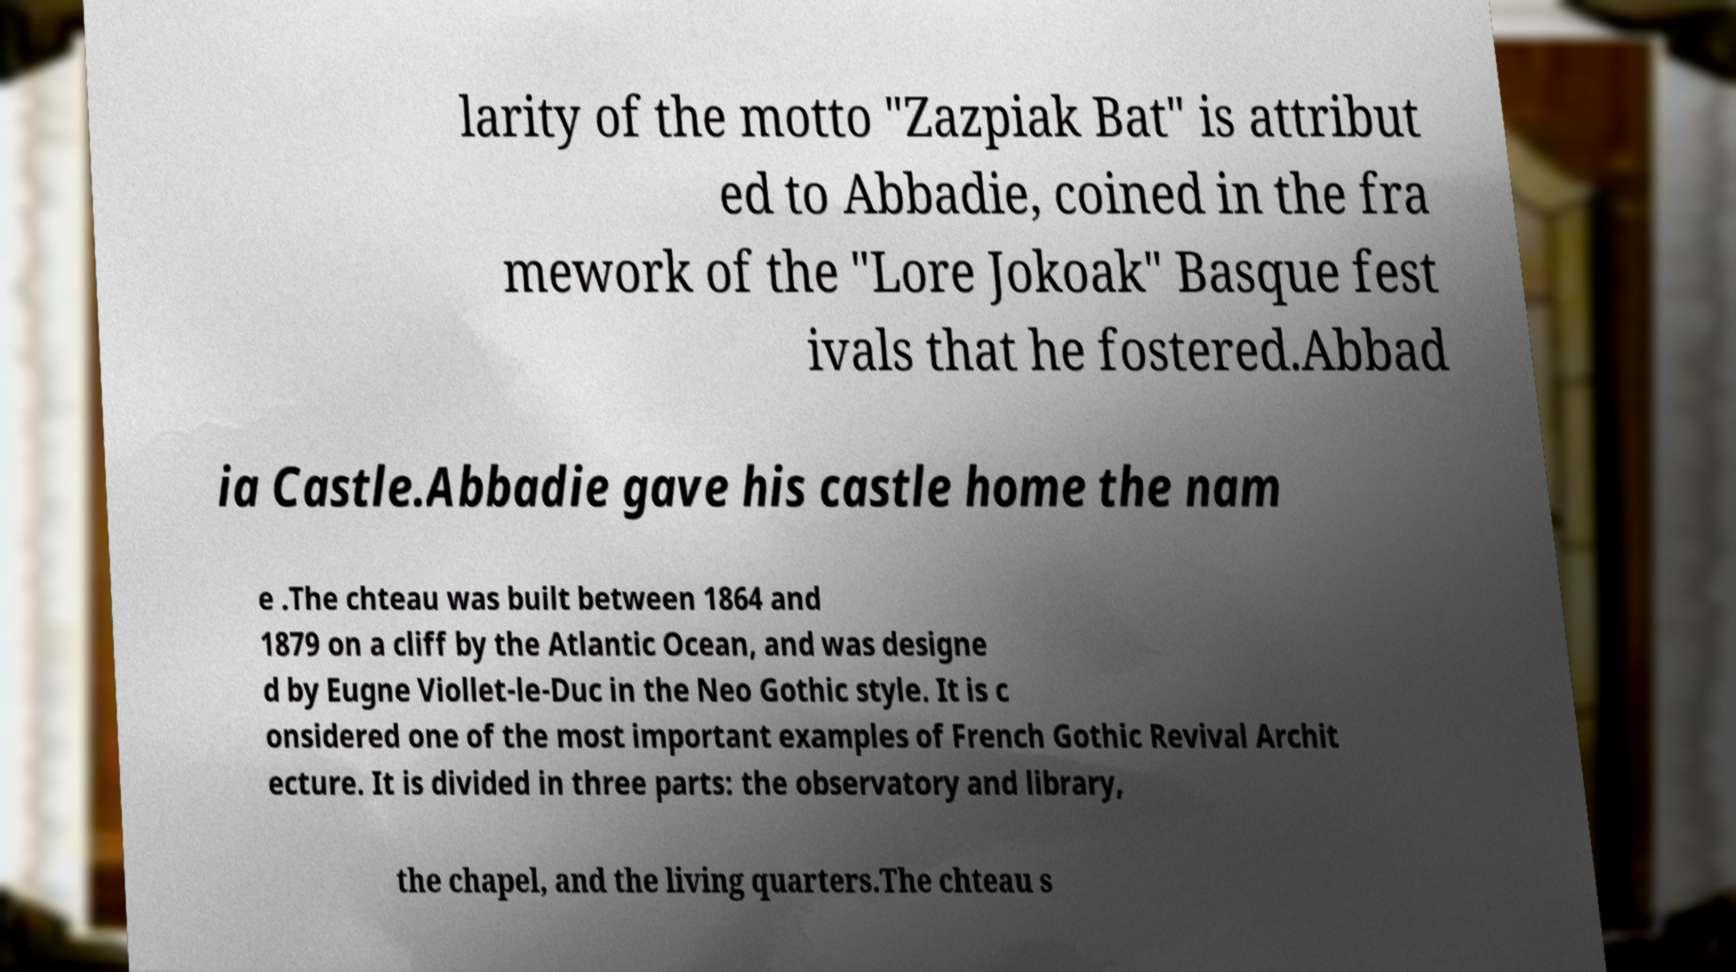Can you read and provide the text displayed in the image?This photo seems to have some interesting text. Can you extract and type it out for me? larity of the motto "Zazpiak Bat" is attribut ed to Abbadie, coined in the fra mework of the "Lore Jokoak" Basque fest ivals that he fostered.Abbad ia Castle.Abbadie gave his castle home the nam e .The chteau was built between 1864 and 1879 on a cliff by the Atlantic Ocean, and was designe d by Eugne Viollet-le-Duc in the Neo Gothic style. It is c onsidered one of the most important examples of French Gothic Revival Archit ecture. It is divided in three parts: the observatory and library, the chapel, and the living quarters.The chteau s 